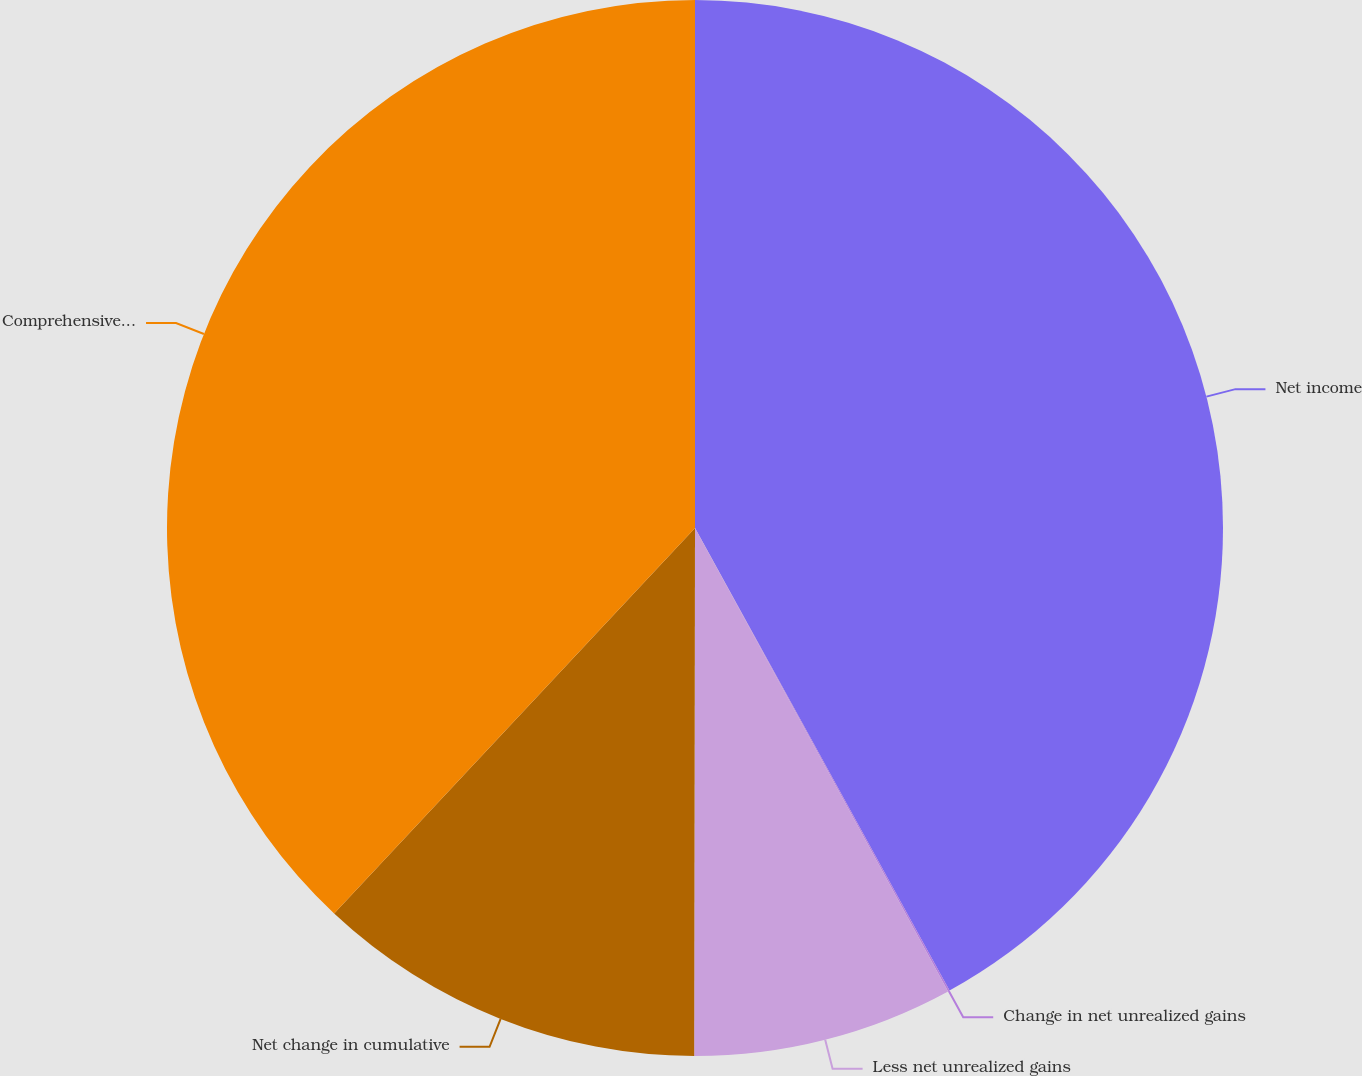Convert chart to OTSL. <chart><loc_0><loc_0><loc_500><loc_500><pie_chart><fcel>Net income<fcel>Change in net unrealized gains<fcel>Less net unrealized gains<fcel>Net change in cumulative<fcel>Comprehensive income<nl><fcel>41.99%<fcel>0.05%<fcel>7.98%<fcel>11.95%<fcel>38.02%<nl></chart> 